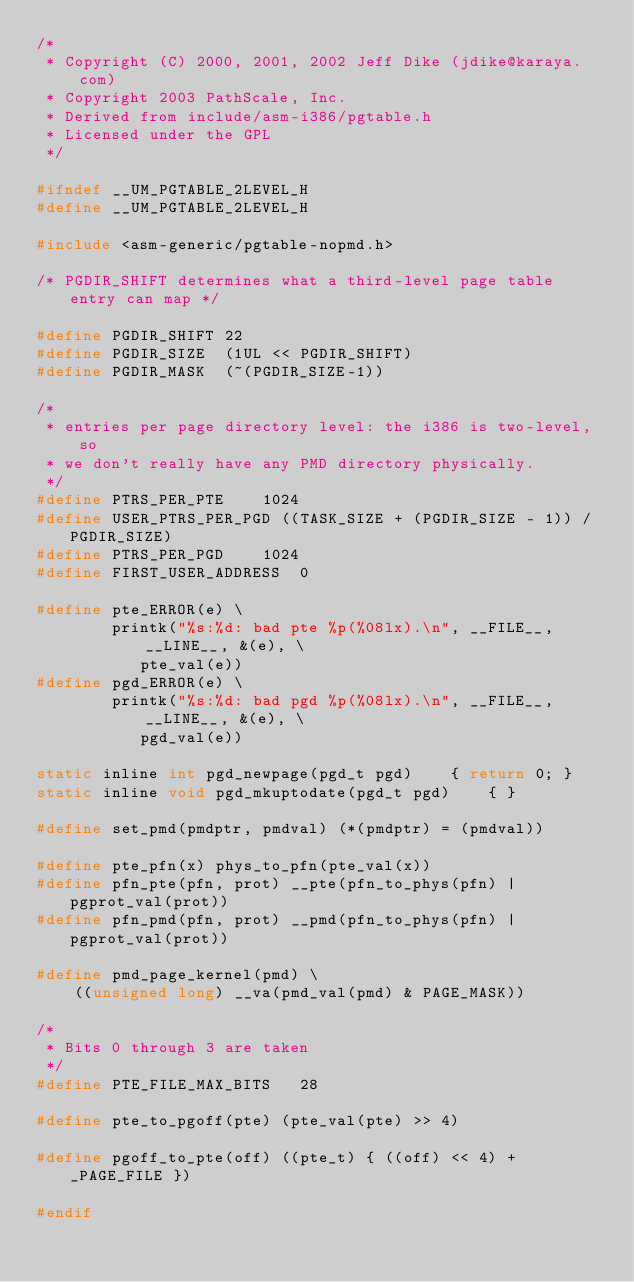Convert code to text. <code><loc_0><loc_0><loc_500><loc_500><_C_>/*
 * Copyright (C) 2000, 2001, 2002 Jeff Dike (jdike@karaya.com)
 * Copyright 2003 PathScale, Inc.
 * Derived from include/asm-i386/pgtable.h
 * Licensed under the GPL
 */

#ifndef __UM_PGTABLE_2LEVEL_H
#define __UM_PGTABLE_2LEVEL_H

#include <asm-generic/pgtable-nopmd.h>

/* PGDIR_SHIFT determines what a third-level page table entry can map */

#define PGDIR_SHIFT	22
#define PGDIR_SIZE	(1UL << PGDIR_SHIFT)
#define PGDIR_MASK	(~(PGDIR_SIZE-1))

/*
 * entries per page directory level: the i386 is two-level, so
 * we don't really have any PMD directory physically.
 */
#define PTRS_PER_PTE	1024
#define USER_PTRS_PER_PGD ((TASK_SIZE + (PGDIR_SIZE - 1)) / PGDIR_SIZE)
#define PTRS_PER_PGD	1024
#define FIRST_USER_ADDRESS	0

#define pte_ERROR(e) \
        printk("%s:%d: bad pte %p(%08lx).\n", __FILE__, __LINE__, &(e), \
	       pte_val(e))
#define pgd_ERROR(e) \
        printk("%s:%d: bad pgd %p(%08lx).\n", __FILE__, __LINE__, &(e), \
	       pgd_val(e))

static inline int pgd_newpage(pgd_t pgd)	{ return 0; }
static inline void pgd_mkuptodate(pgd_t pgd)	{ }

#define set_pmd(pmdptr, pmdval) (*(pmdptr) = (pmdval))

#define pte_pfn(x) phys_to_pfn(pte_val(x))
#define pfn_pte(pfn, prot) __pte(pfn_to_phys(pfn) | pgprot_val(prot))
#define pfn_pmd(pfn, prot) __pmd(pfn_to_phys(pfn) | pgprot_val(prot))

#define pmd_page_kernel(pmd) \
	((unsigned long) __va(pmd_val(pmd) & PAGE_MASK))

/*
 * Bits 0 through 3 are taken
 */
#define PTE_FILE_MAX_BITS	28

#define pte_to_pgoff(pte) (pte_val(pte) >> 4)

#define pgoff_to_pte(off) ((pte_t) { ((off) << 4) + _PAGE_FILE })

#endif
</code> 